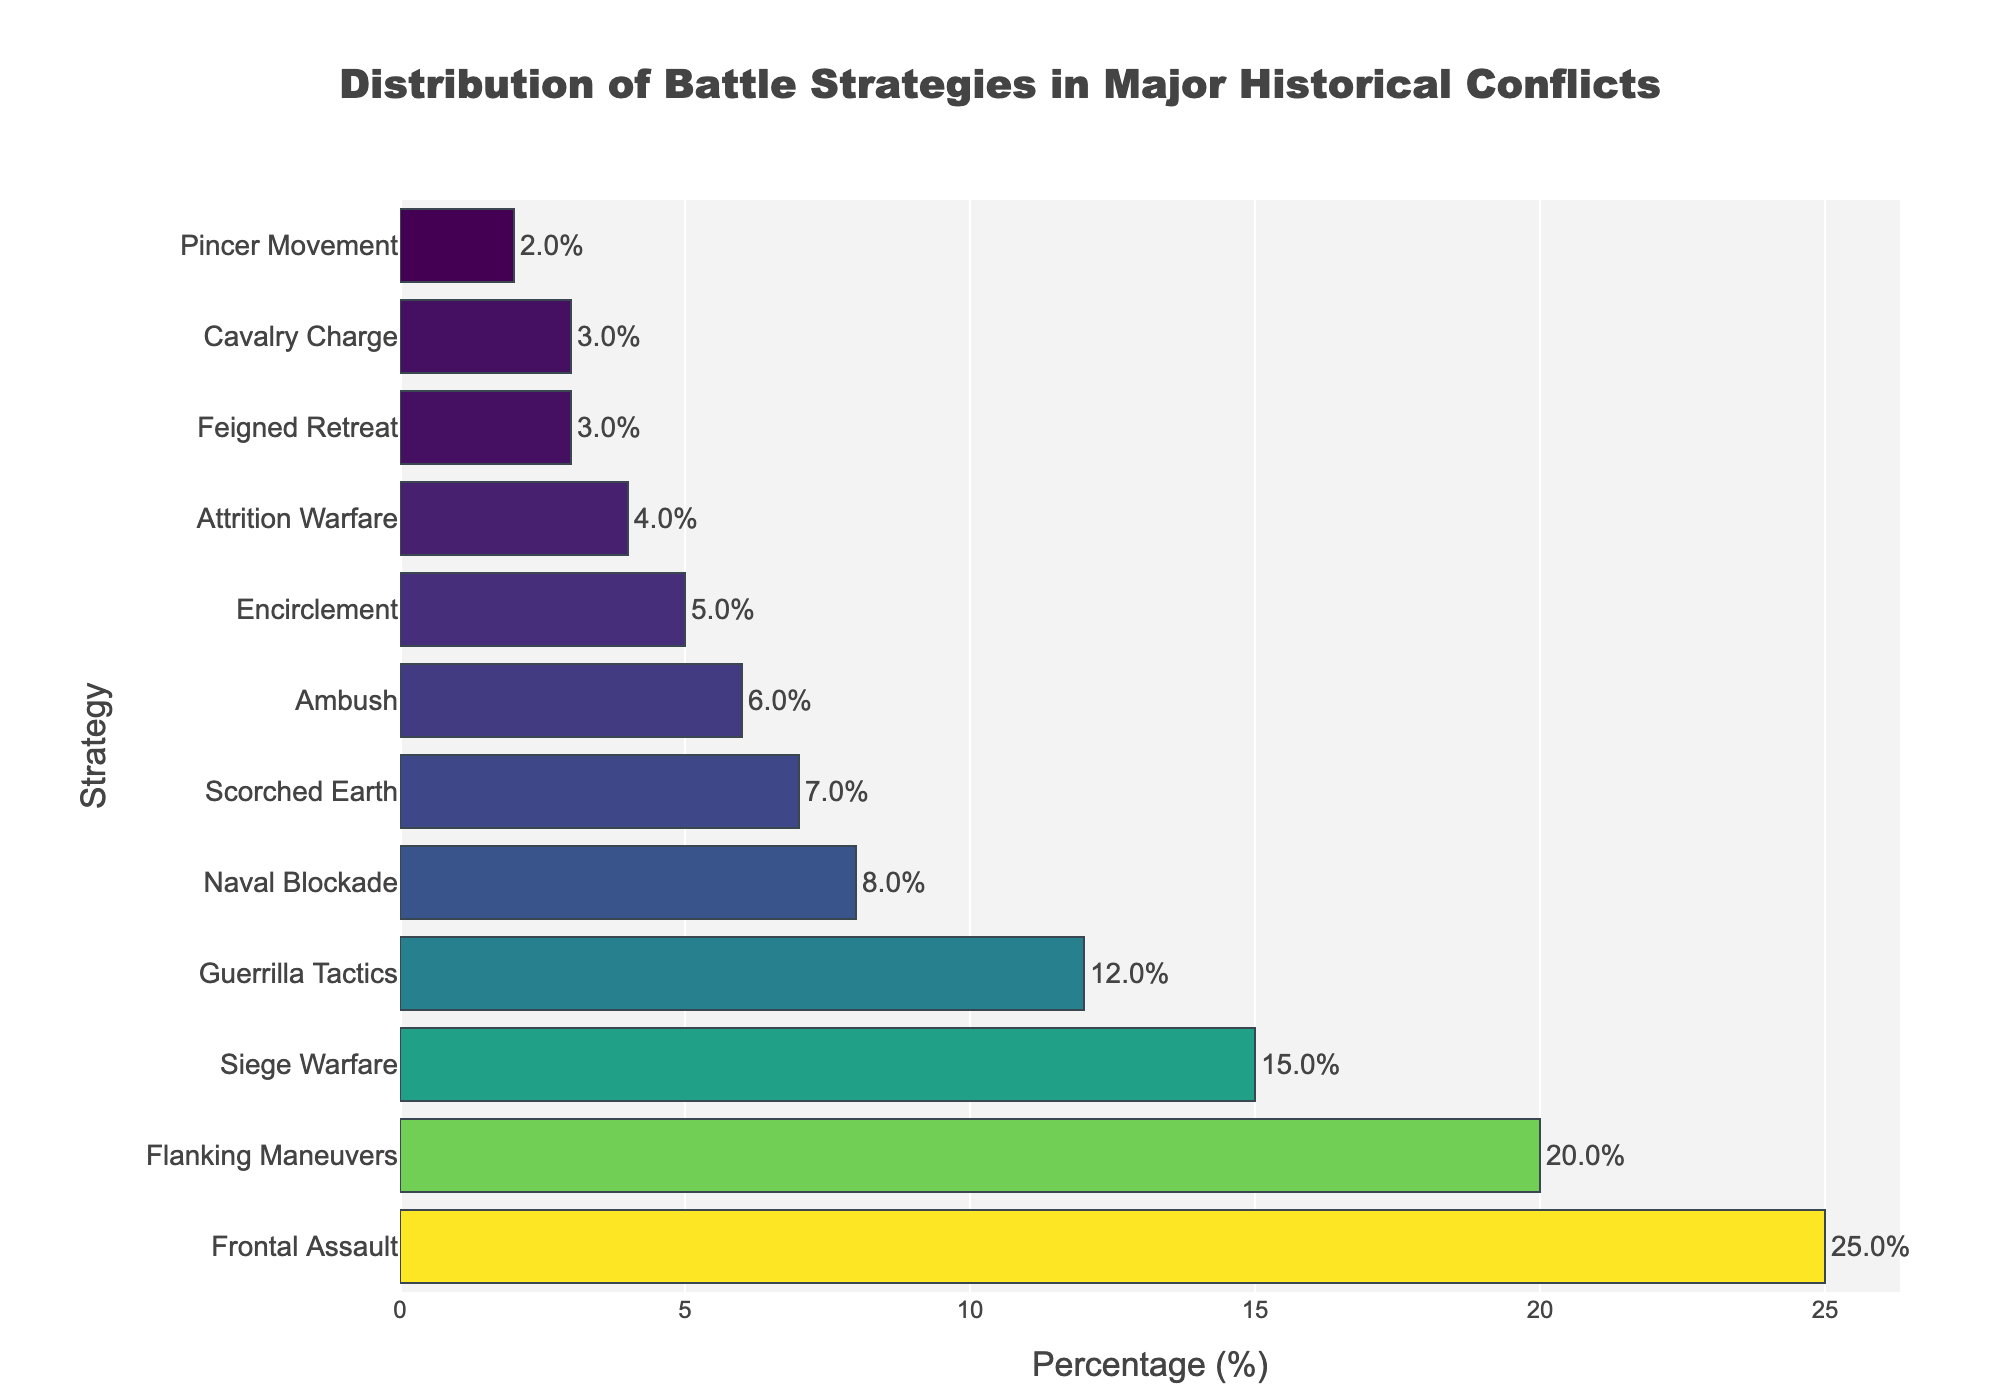Which strategy has the highest percentage? From the bar chart, we observe that the 'Frontal Assault' bar is the longest and hence has the highest percentage. The percentage at the end of this bar reads 25%.
Answer: Frontal Assault What is the combined percentage of 'Flanking Maneuvers' and 'Siege Warfare'? To find the combined percentage, add the percentage values for 'Flanking Maneuvers' and 'Siege Warfare'. 'Flanking Maneuvers' is 20% and 'Siege Warfare' is 15%, so 20% + 15% = 35%.
Answer: 35% Which strategy is used exactly half as much as 'Guerrilla Tactics'? 'Guerrilla Tactics' has a percentage of 12%. Half of 12% is 6%, which is the percentage for the strategy 'Ambush'.
Answer: Ambush How many strategies have a percentage greater than 10%? From the chart, look at the bars with percentages greater than 10%. These are for 'Frontal Assault' (25%), 'Flanking Maneuvers' (20%), 'Siege Warfare' (15%), and 'Guerrilla Tactics' (12%). There are 4 such strategies.
Answer: 4 What is the percentage difference between 'Naval Blockade' and 'Scorched Earth'? The percentage for 'Naval Blockade' is 8% and for 'Scorched Earth' is 7%. The difference is 8% - 7% = 1%.
Answer: 1% Is 'Feigned Retreat' used more or less frequently than 'Cavalry Charge'? Compare the percentages directly from the chart: 'Feigned Retreat' has 3% whereas 'Cavalry Charge' also has 3%. Therefore, they are used equally.
Answer: Equally What is the average percentage of 'Ambush', 'Encirclement', and 'Attrition Warfare'? Add the percentages for 'Ambush' (6%), 'Encirclement' (5%), and 'Attrition Warfare' (4%), then divide by the number of strategies. (6% + 5% + 4%) / 3 = 15% / 3 = 5%.
Answer: 5% Which strategy has a lower percentage, 'Scorched Earth' or 'Attrition Warfare'? 'Scorched Earth' has a percentage of 7%, and 'Attrition Warfare' has a percentage of 4%. Therefore, 'Attrition Warfare' has the lower percentage.
Answer: Attrition Warfare What is the total percentage for all strategies used? Sum the percentages for all the strategies from the chart: 25% + 20% + 15% + 12% + 8% + 7% + 6% + 5% + 4% + 3% + 3% + 2% = 110%.
Answer: 110% Which strategy is represented with the shortest bar? From the bar chart, 'Pincer Movement' is represented with the shortest bar, with a percentage of 2%.
Answer: Pincer Movement 